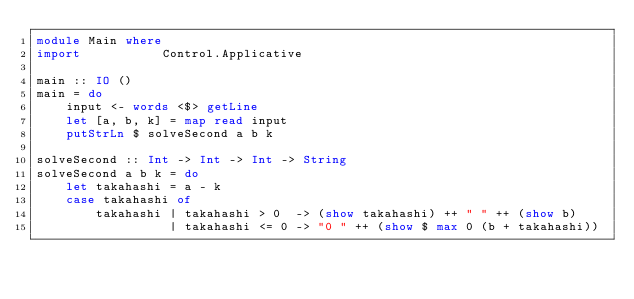Convert code to text. <code><loc_0><loc_0><loc_500><loc_500><_Haskell_>module Main where
import           Control.Applicative

main :: IO ()
main = do
    input <- words <$> getLine
    let [a, b, k] = map read input
    putStrLn $ solveSecond a b k

solveSecond :: Int -> Int -> Int -> String
solveSecond a b k = do
    let takahashi = a - k
    case takahashi of
        takahashi | takahashi > 0  -> (show takahashi) ++ " " ++ (show b)
                  | takahashi <= 0 -> "0 " ++ (show $ max 0 (b + takahashi))
</code> 